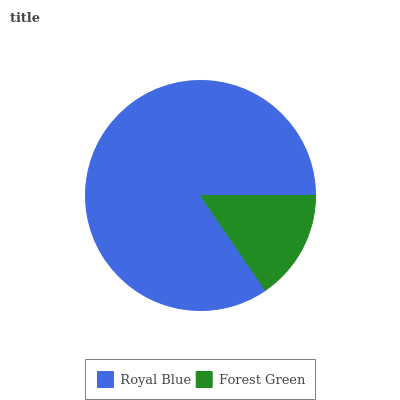Is Forest Green the minimum?
Answer yes or no. Yes. Is Royal Blue the maximum?
Answer yes or no. Yes. Is Forest Green the maximum?
Answer yes or no. No. Is Royal Blue greater than Forest Green?
Answer yes or no. Yes. Is Forest Green less than Royal Blue?
Answer yes or no. Yes. Is Forest Green greater than Royal Blue?
Answer yes or no. No. Is Royal Blue less than Forest Green?
Answer yes or no. No. Is Royal Blue the high median?
Answer yes or no. Yes. Is Forest Green the low median?
Answer yes or no. Yes. Is Forest Green the high median?
Answer yes or no. No. Is Royal Blue the low median?
Answer yes or no. No. 